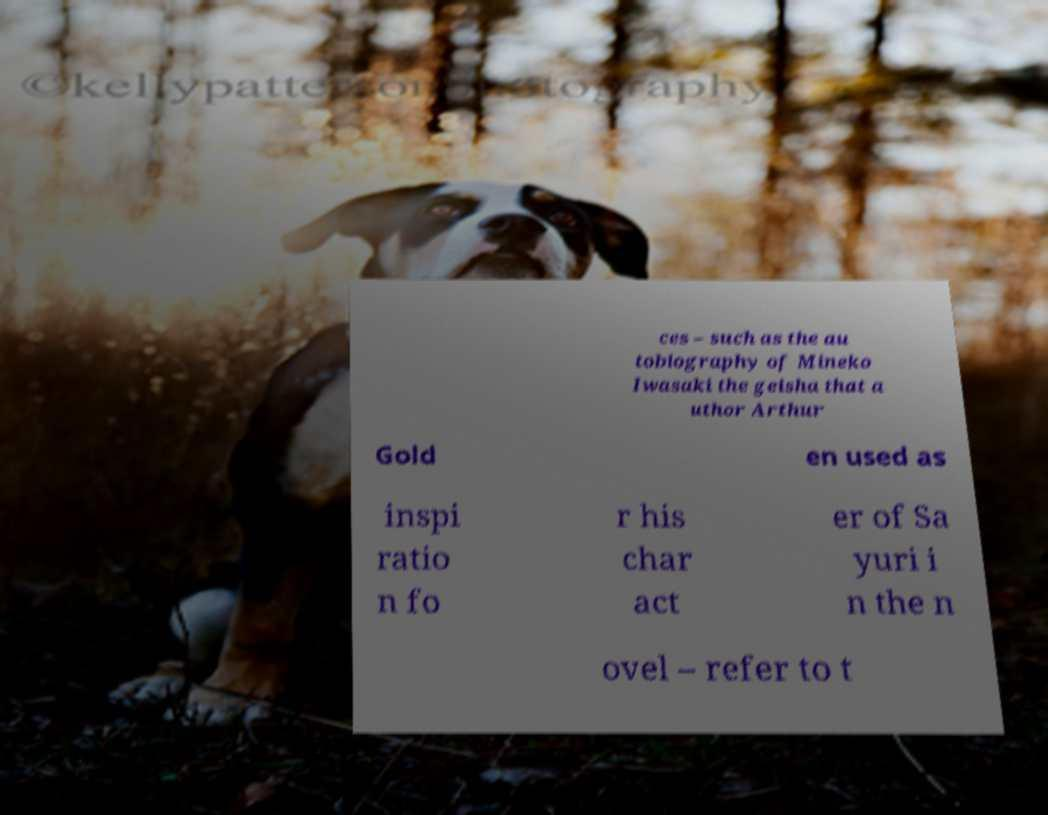I need the written content from this picture converted into text. Can you do that? ces – such as the au tobiography of Mineko Iwasaki the geisha that a uthor Arthur Gold en used as inspi ratio n fo r his char act er of Sa yuri i n the n ovel – refer to t 